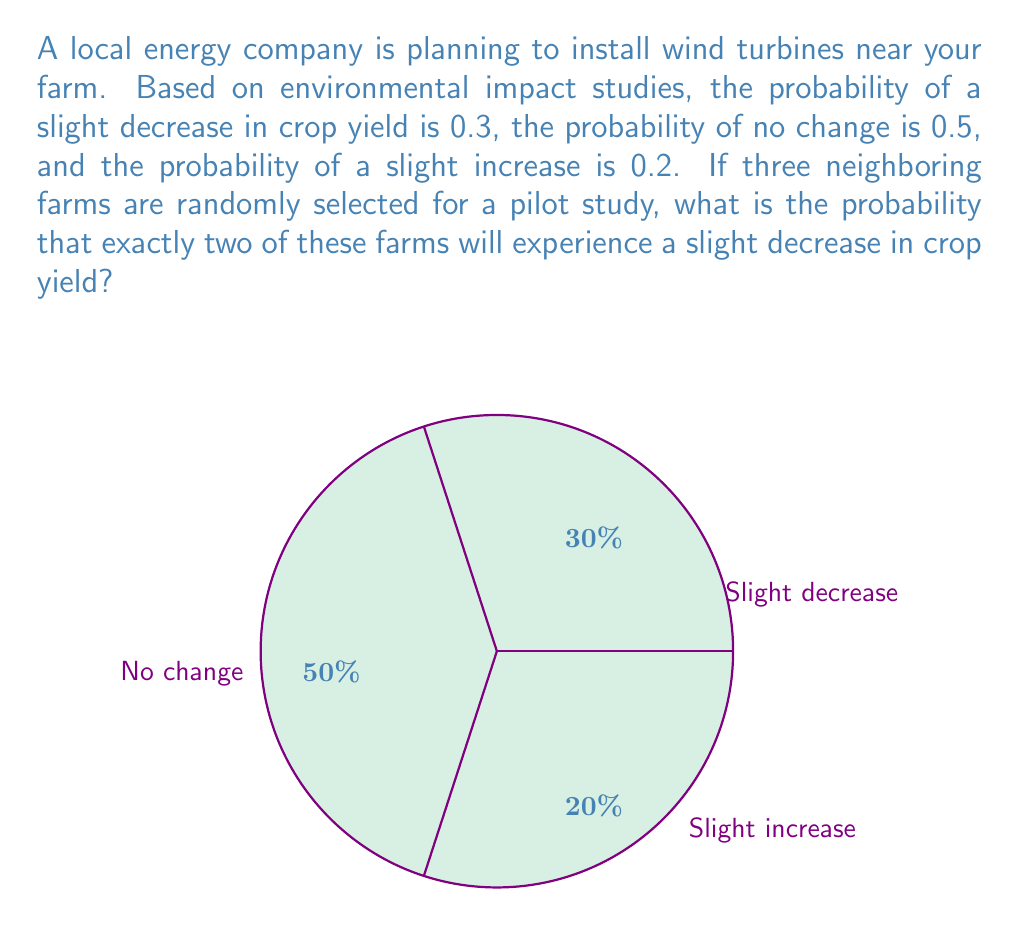Solve this math problem. To solve this problem, we can use the binomial probability distribution. The binomial distribution is appropriate when we have a fixed number of independent trials, each with the same probability of success.

Let's define our parameters:
- $n = 3$ (number of farms)
- $p = 0.3$ (probability of slight decrease in crop yield)
- $k = 2$ (number of farms we want to experience a slight decrease)

The probability mass function for the binomial distribution is:

$$ P(X = k) = \binom{n}{k} p^k (1-p)^{n-k} $$

where $\binom{n}{k}$ is the binomial coefficient, calculated as:

$$ \binom{n}{k} = \frac{n!}{k!(n-k)!} $$

Let's solve step by step:

1) Calculate the binomial coefficient:
   $\binom{3}{2} = \frac{3!}{2!(3-2)!} = \frac{3 \cdot 2 \cdot 1}{(2 \cdot 1)(1)} = 3$

2) Plug the values into the probability mass function:
   $P(X = 2) = 3 \cdot (0.3)^2 \cdot (1-0.3)^{3-2}$

3) Simplify:
   $P(X = 2) = 3 \cdot (0.3)^2 \cdot (0.7)^1$
   $P(X = 2) = 3 \cdot 0.09 \cdot 0.7$
   $P(X = 2) = 0.189$

Therefore, the probability that exactly two out of three randomly selected farms will experience a slight decrease in crop yield is 0.189 or 18.9%.
Answer: 0.189 